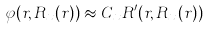<formula> <loc_0><loc_0><loc_500><loc_500>\varphi ( r , R _ { x } ( r ) ) \approx C _ { x } R ^ { \prime } ( r , R _ { x } ( r ) )</formula> 